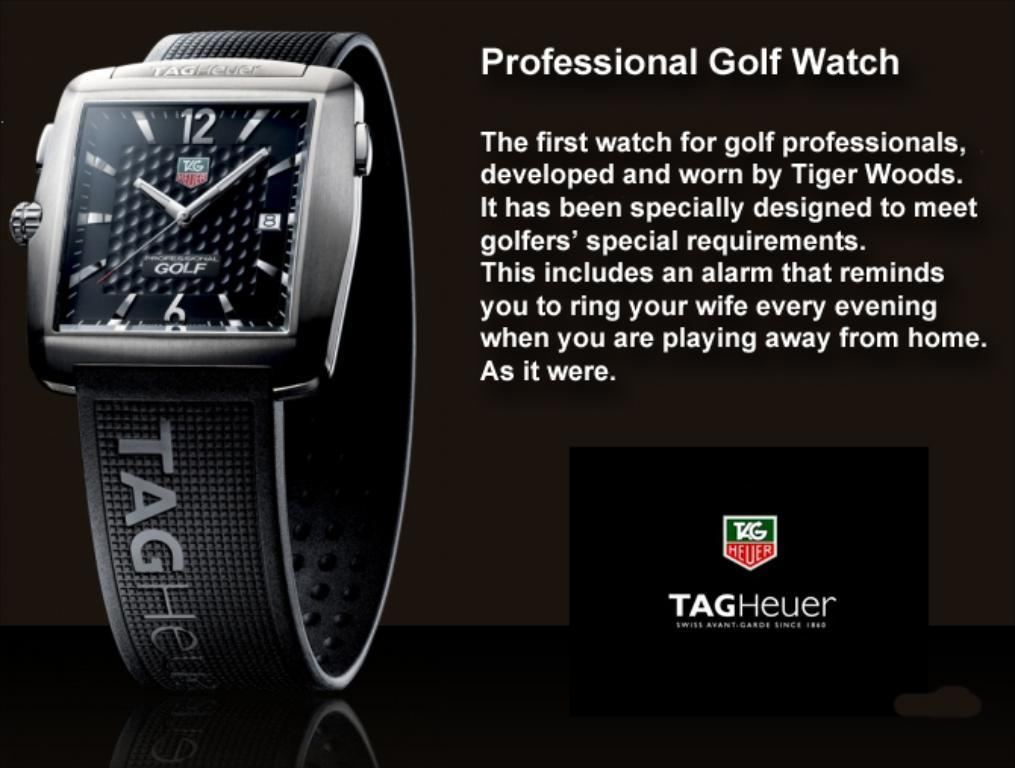Provide a one-sentence caption for the provided image. A professional golf watch developed by Tiger Woods. 